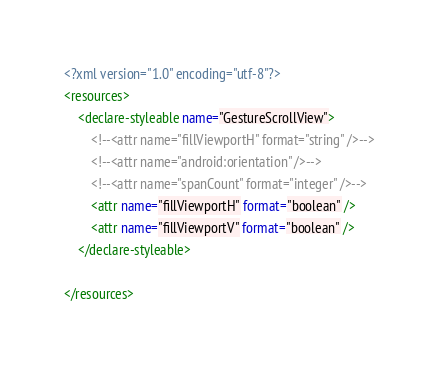Convert code to text. <code><loc_0><loc_0><loc_500><loc_500><_XML_><?xml version="1.0" encoding="utf-8"?>
<resources>
    <declare-styleable name="GestureScrollView">
        <!--<attr name="fillViewportH" format="string" />-->
        <!--<attr name="android:orientation" />-->
        <!--<attr name="spanCount" format="integer" />-->
        <attr name="fillViewportH" format="boolean" />
        <attr name="fillViewportV" format="boolean" />
    </declare-styleable>

</resources></code> 